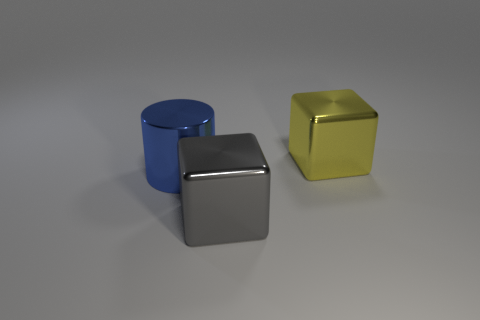Add 3 cubes. How many objects exist? 6 Subtract all cylinders. How many objects are left? 2 Subtract all large metallic things. Subtract all large gray matte cubes. How many objects are left? 0 Add 3 large metallic cylinders. How many large metallic cylinders are left? 4 Add 1 small cyan rubber things. How many small cyan rubber things exist? 1 Subtract 0 gray balls. How many objects are left? 3 